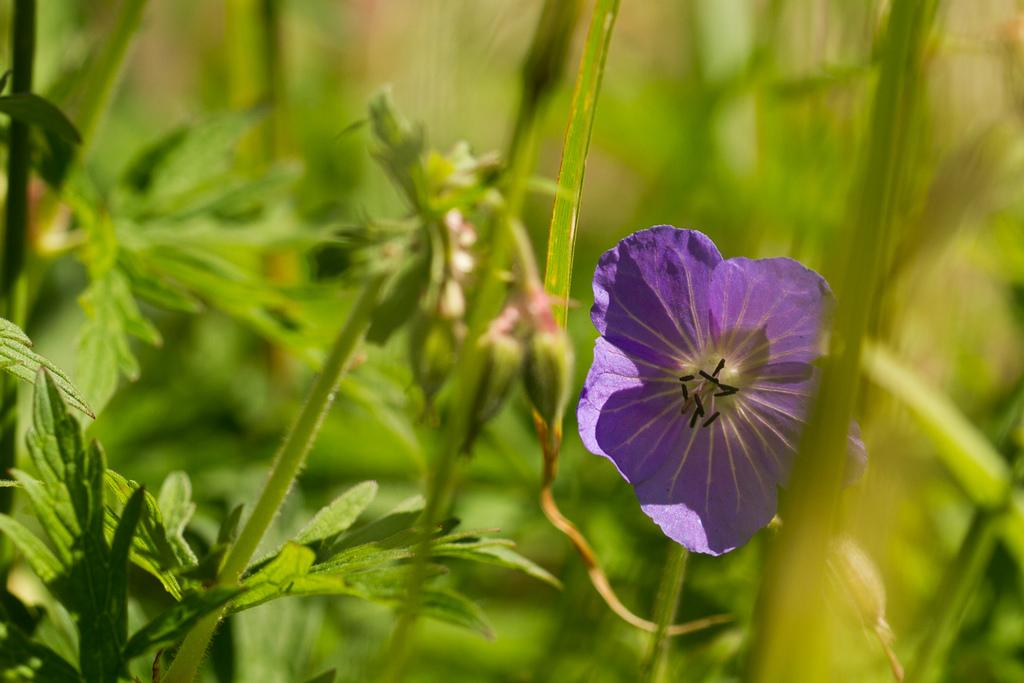What type of living organism can be seen in the image? There is a flower in the image. Are there any other similar living organisms in the image? Yes, there are plants in the image. What type of voyage is the flower embarking on in the image? The flower is not embarking on any voyage in the image; it is stationary. 